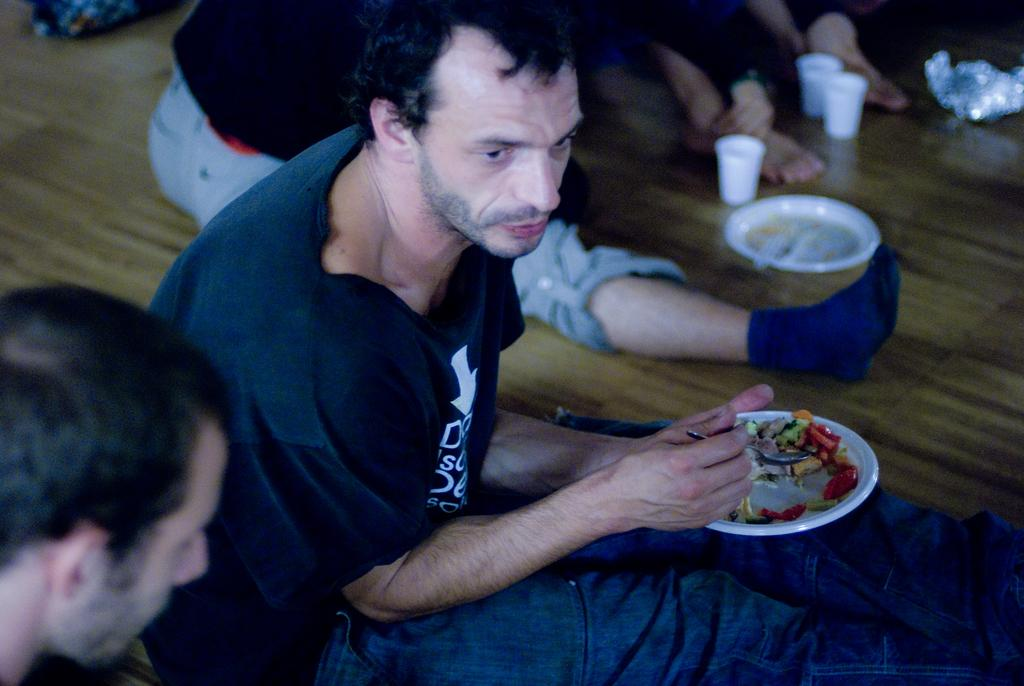What are the people in the image doing? The people in the image are sitting on the ground. What is one person holding in the image? One person is holding a plate and a spoon. What objects can be seen on the floor in the image? There are plates and cups on the floor. What type of receipt can be seen in the image? There is no receipt present in the image. Is there a lawyer sitting among the people in the image? There is no indication of a lawyer or any legal profession in the image. 